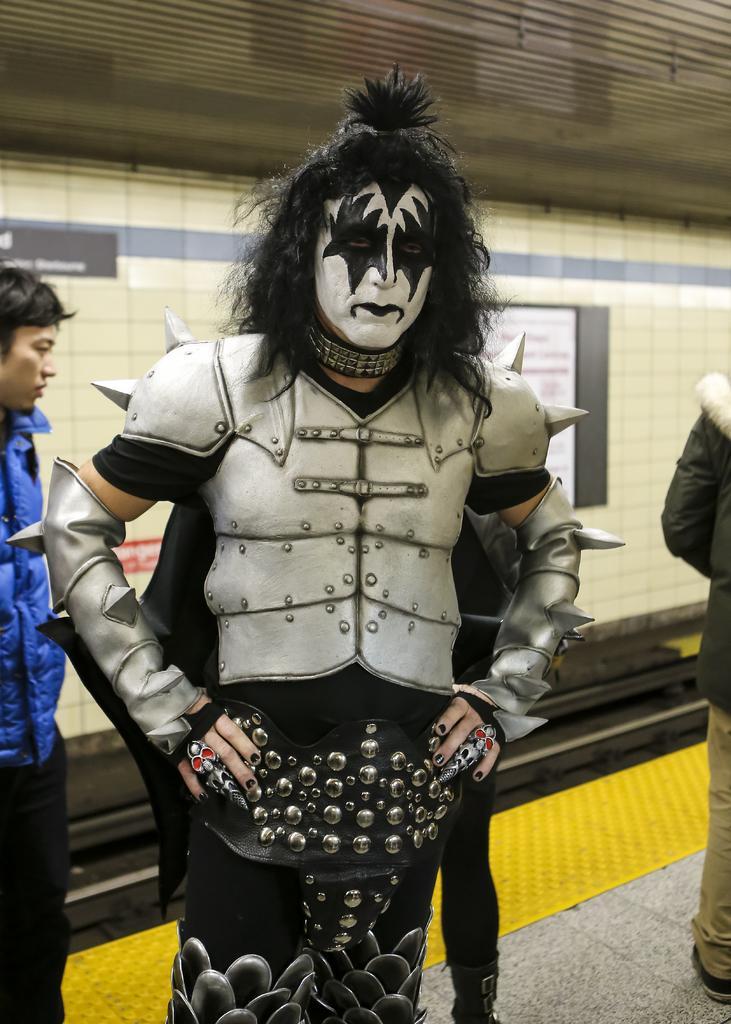In one or two sentences, can you explain what this image depicts? In this image I can see few people are standing and in the front I can see one of them is wearing costume. In the background I can see few boards. 